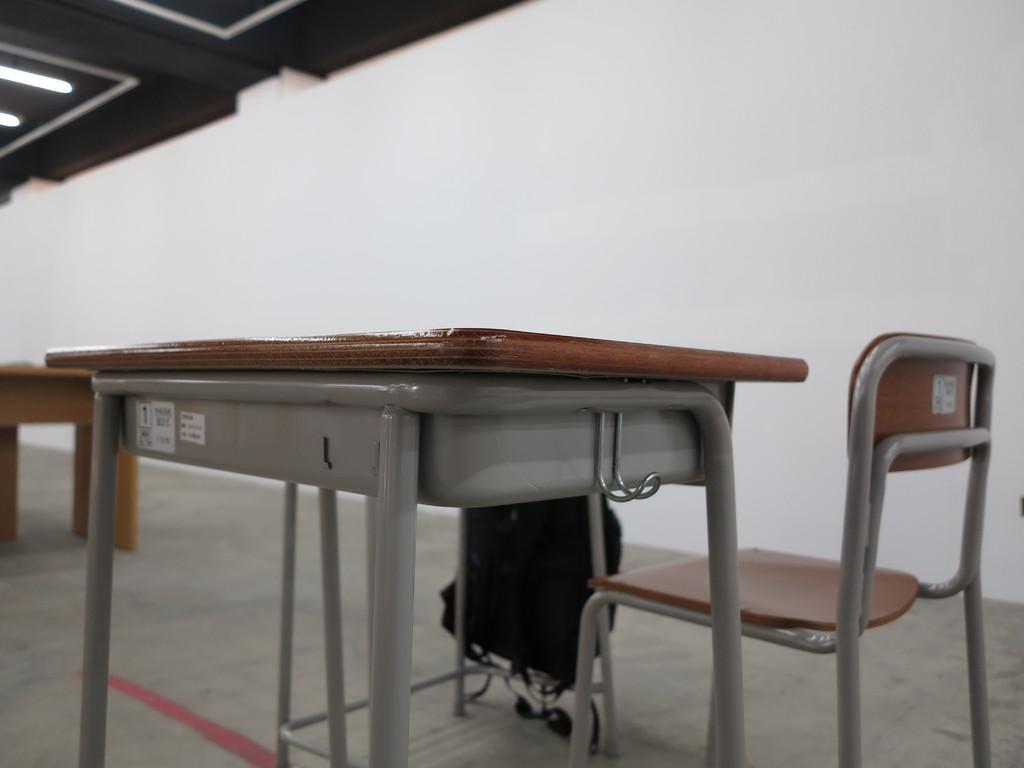Could you give a brief overview of what you see in this image? In the picture we can see a table and a chair and to the table we can see a bag and beside the table we can see a part of another table and to the ceiling we can see lights. 